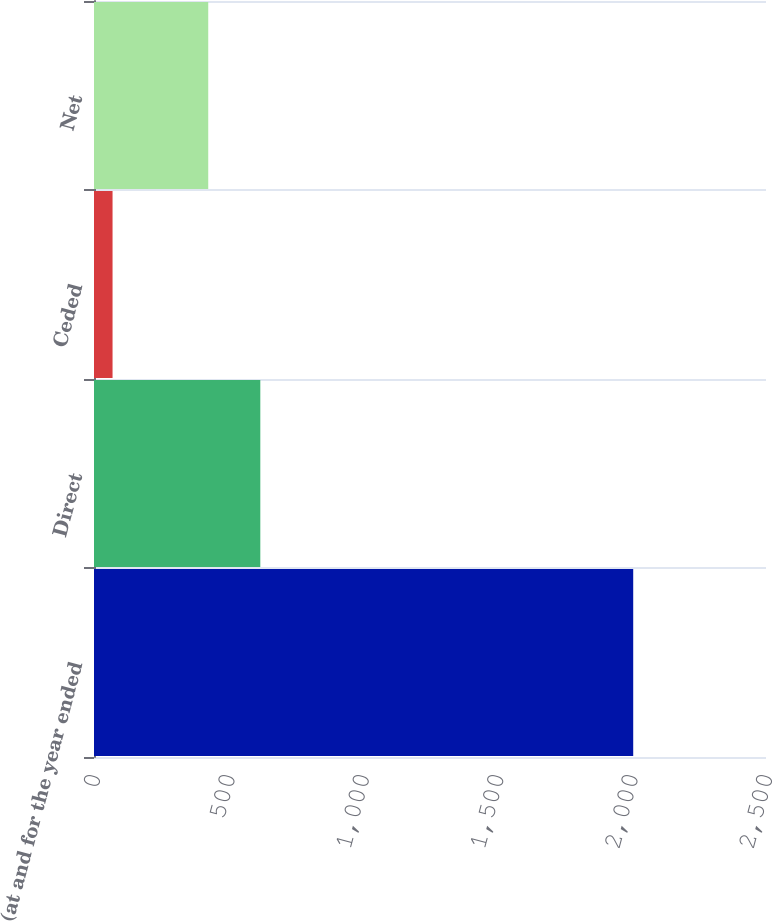Convert chart to OTSL. <chart><loc_0><loc_0><loc_500><loc_500><bar_chart><fcel>(at and for the year ended<fcel>Direct<fcel>Ceded<fcel>Net<nl><fcel>2006<fcel>618.7<fcel>69<fcel>425<nl></chart> 